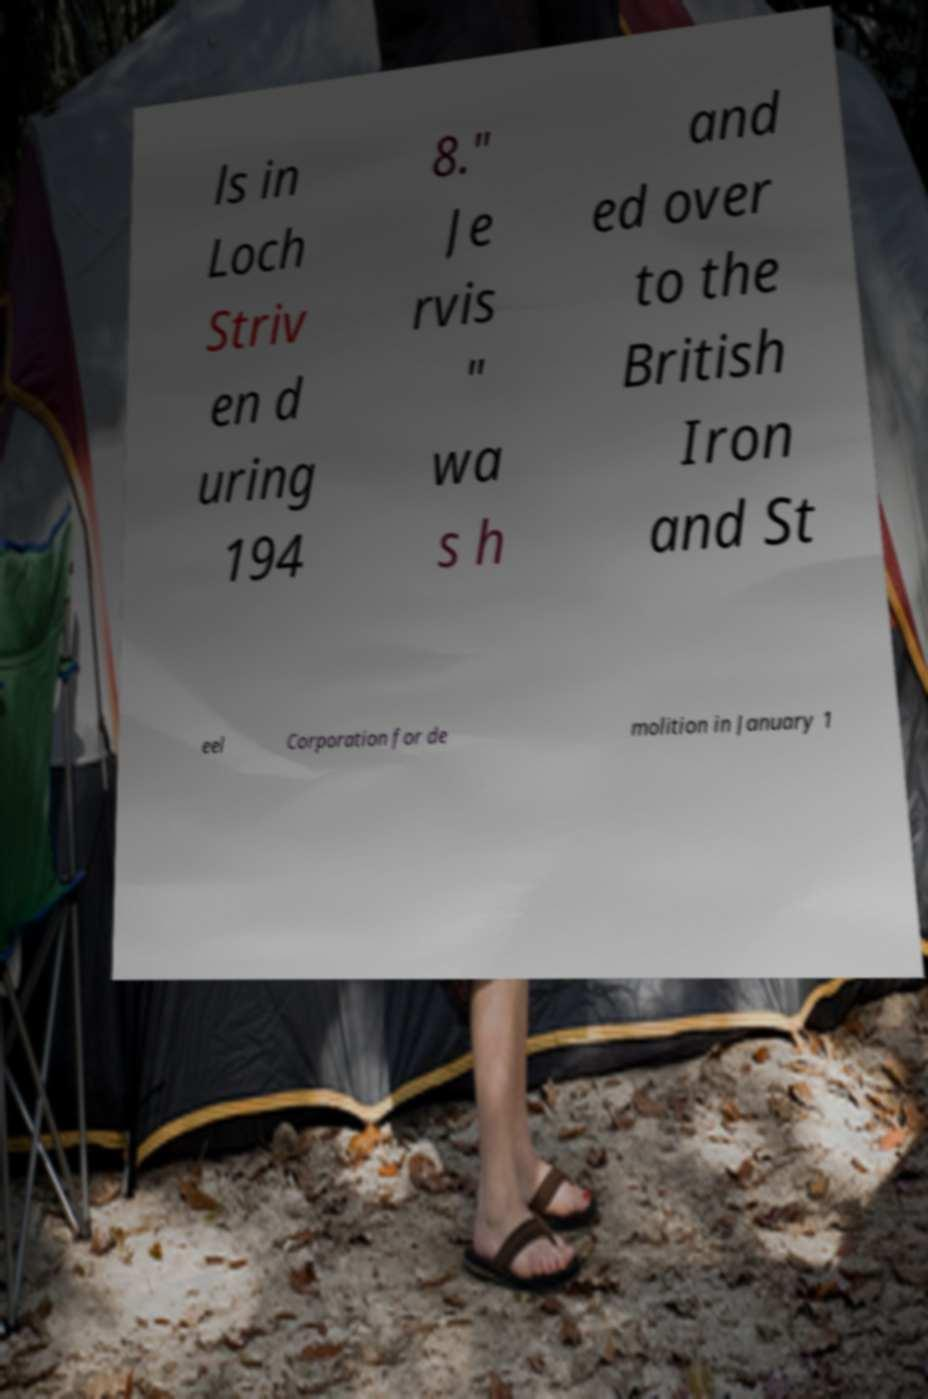I need the written content from this picture converted into text. Can you do that? ls in Loch Striv en d uring 194 8." Je rvis " wa s h and ed over to the British Iron and St eel Corporation for de molition in January 1 